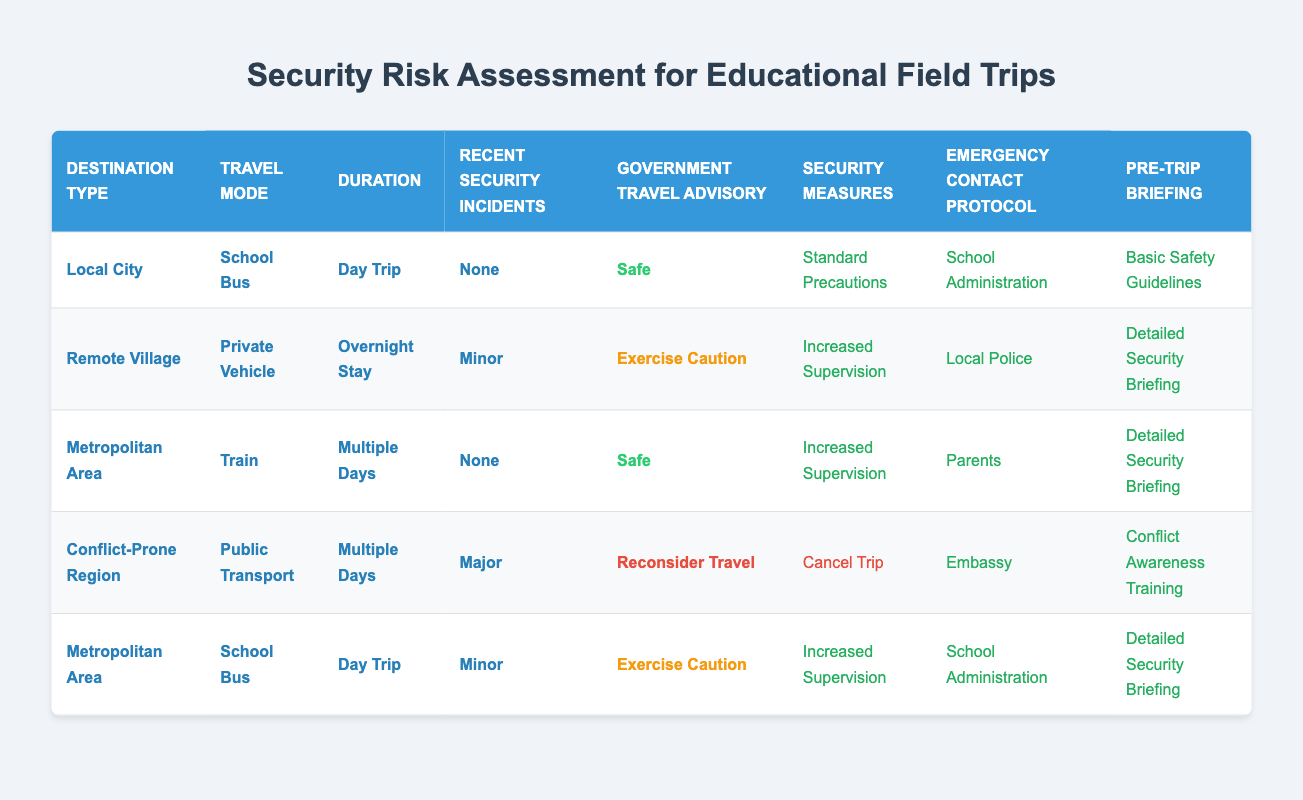What security measures are recommended for a field trip to a conflict-prone region? The table clearly indicates that in a conflict-prone region with major recent security incidents and a government advisory to reconsider travel, the recommended security measure is to cancel the trip.
Answer: Cancel Trip What type of travel mode is suggested for a day trip to a local city? According to the table, the preferred travel mode for a day trip to a local city is by school bus, as suggested by the row detailing that specific scenario.
Answer: School Bus How many emergency contact protocols are listed for field trips in the table? The table lists four different emergency contact protocols: School Administration, Local Police, Parents, and Embassy. Therefore, the total count of unique emergency contact protocols is four.
Answer: 4 Is increased supervision necessary for a field trip to a remote village with minor recent security incidents? Yes, the table specifies that for a field trip to a remote village with minor recent security incidents and an advisory to exercise caution, increased supervision is advised.
Answer: Yes What combination of factors leads to cancellation of a trip? To evaluate the combination that leads to trip cancellation, we look for the row detailing conditions that require this action. The factors include being in a conflict-prone region, using public transport, having a duration of multiple days, recent major security incidents, and a government advisory to reconsider travel. All these contribute to the conclusion that the trip should be canceled.
Answer: Conflict-Prone Region, Public Transport, Multiple Days, Major, Reconsider Travel What is the recommended pre-trip briefing for a trip to a metropolitan area by train, lasting multiple days with no recent security incidents? In the table, it is indicated that a trip to a metropolitan area by train for multiple days with no recent incidents should have a detailed security briefing as a pre-trip preparation, according to the relevant row.
Answer: Detailed Security Briefing Based on the table, does a day trip to a metropolitan area require increased supervision if there has been a minor recent security incident? Yes, the table indicates that in the case of a day trip to a metropolitan area with minor recent security incidents and a government advisory to exercise caution, increased supervision is a necessary security measure.
Answer: Yes What are the emergency contact protocols for a field trip with increased supervision to a remote village? For a field trip to a remote village that requires increased supervision due to minor recent security incidents, the emergency contact protocol listed is local police, per the row that summarizes this scenario in the table.
Answer: Local Police How many different security measures are available in the table? The table provides four different security measures: Standard Precautions, Increased Supervision, Security Personnel, and Cancel Trip. This leads to a total of four unique measures listed.
Answer: 4 